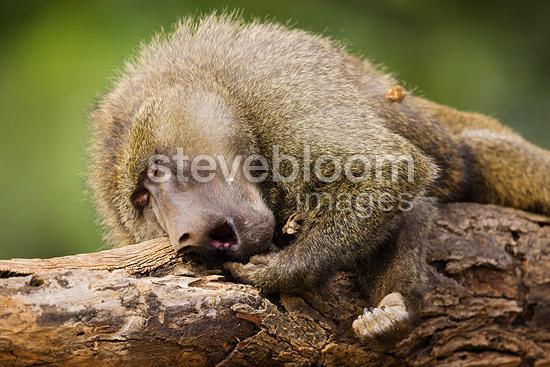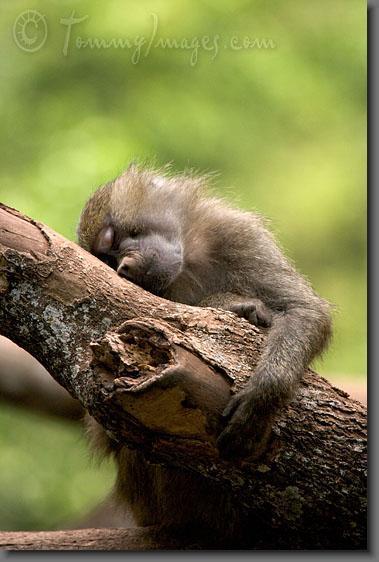The first image is the image on the left, the second image is the image on the right. Given the left and right images, does the statement "One of these lesser apes is carrying a younger primate." hold true? Answer yes or no. No. The first image is the image on the left, the second image is the image on the right. Examine the images to the left and right. Is the description "a baby baboon is riding on its mothers back" accurate? Answer yes or no. No. 